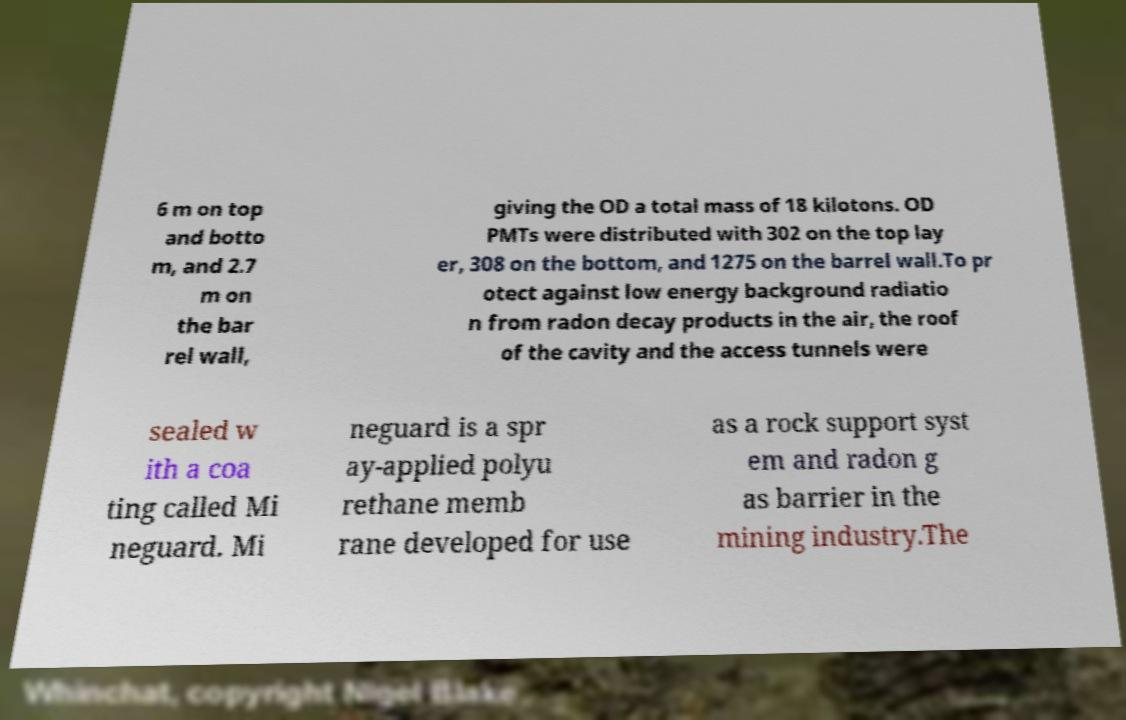Could you extract and type out the text from this image? 6 m on top and botto m, and 2.7 m on the bar rel wall, giving the OD a total mass of 18 kilotons. OD PMTs were distributed with 302 on the top lay er, 308 on the bottom, and 1275 on the barrel wall.To pr otect against low energy background radiatio n from radon decay products in the air, the roof of the cavity and the access tunnels were sealed w ith a coa ting called Mi neguard. Mi neguard is a spr ay-applied polyu rethane memb rane developed for use as a rock support syst em and radon g as barrier in the mining industry.The 